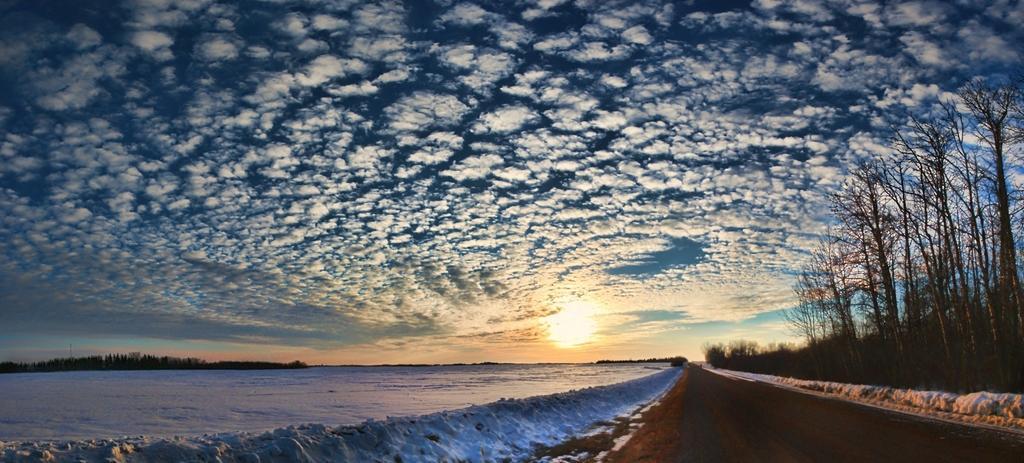Can you describe this image briefly? In this image we can see a road, snow, and trees. In the background there is sky with clouds. 